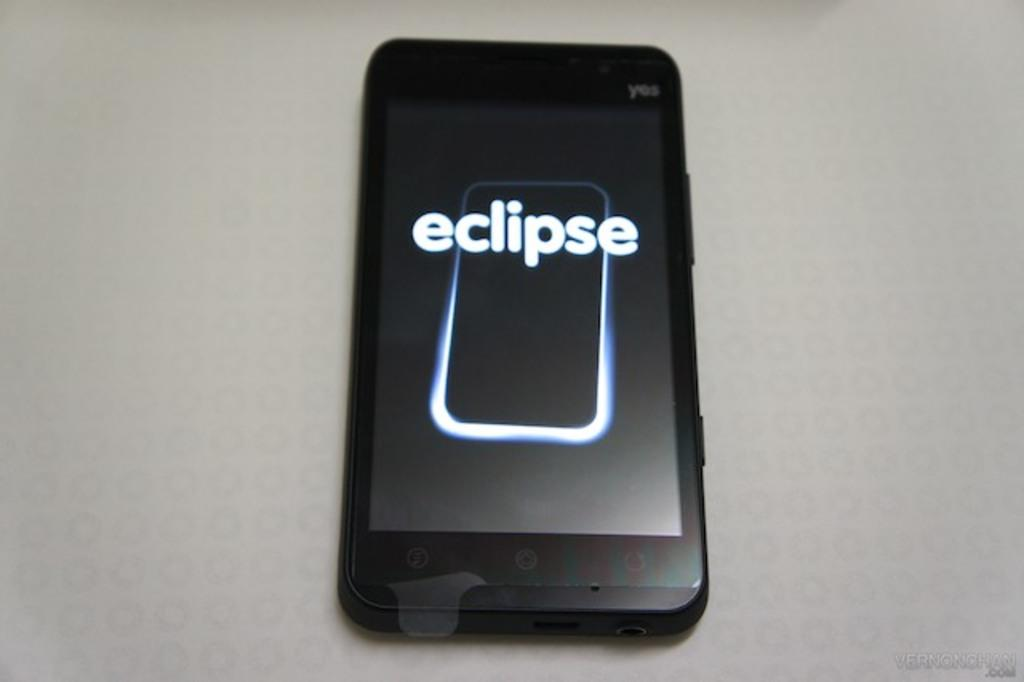<image>
Offer a succinct explanation of the picture presented. An Eclipse brand cellphone sitting on a white table. 